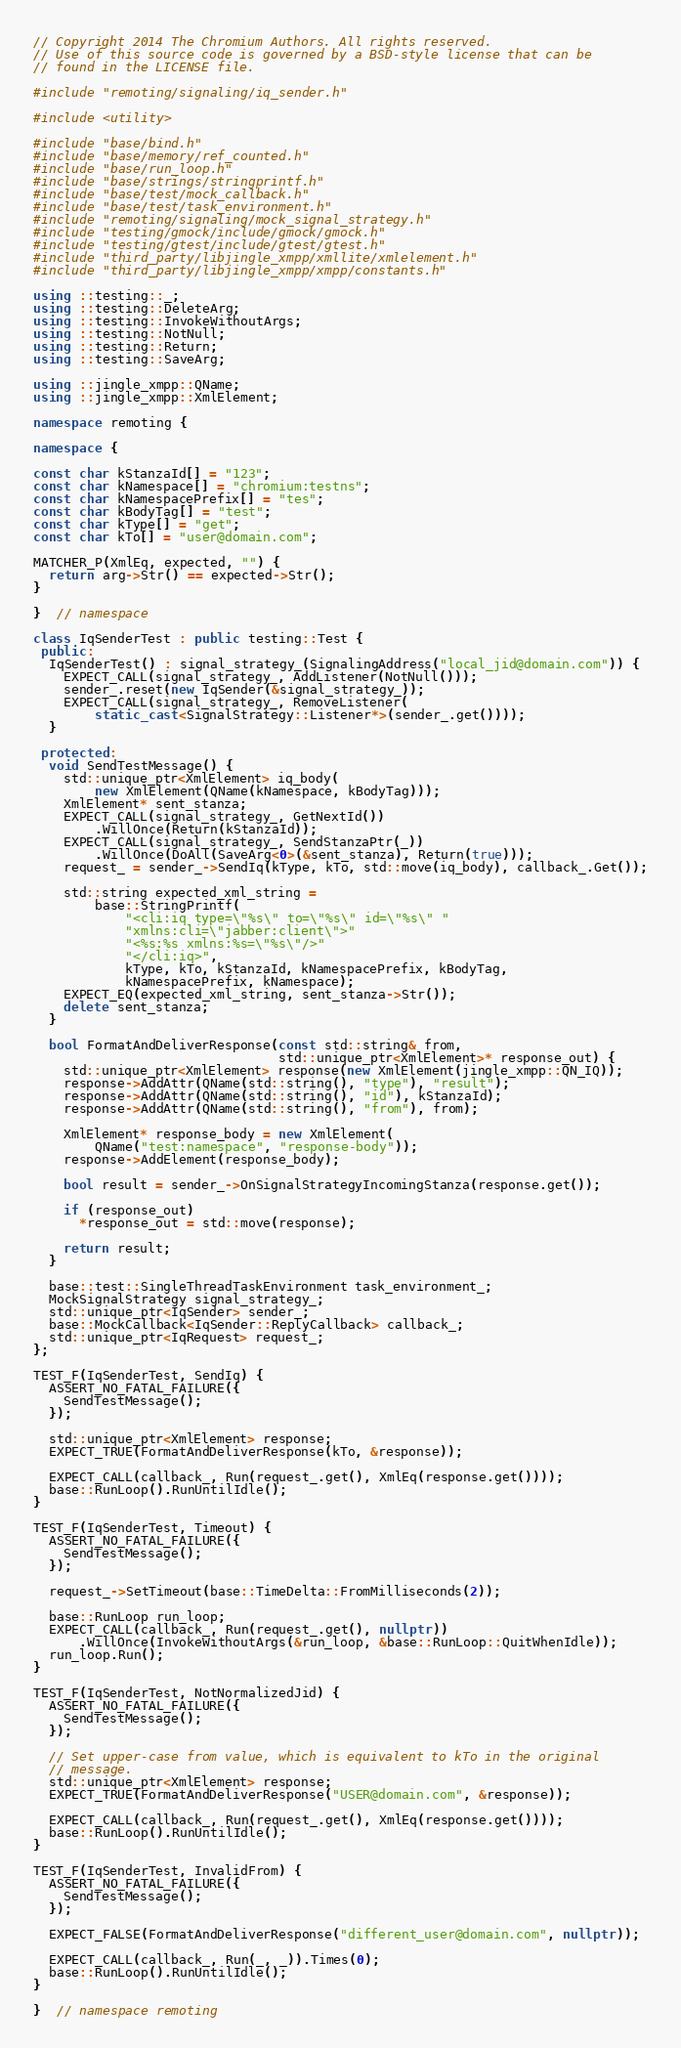Convert code to text. <code><loc_0><loc_0><loc_500><loc_500><_C++_>// Copyright 2014 The Chromium Authors. All rights reserved.
// Use of this source code is governed by a BSD-style license that can be
// found in the LICENSE file.

#include "remoting/signaling/iq_sender.h"

#include <utility>

#include "base/bind.h"
#include "base/memory/ref_counted.h"
#include "base/run_loop.h"
#include "base/strings/stringprintf.h"
#include "base/test/mock_callback.h"
#include "base/test/task_environment.h"
#include "remoting/signaling/mock_signal_strategy.h"
#include "testing/gmock/include/gmock/gmock.h"
#include "testing/gtest/include/gtest/gtest.h"
#include "third_party/libjingle_xmpp/xmllite/xmlelement.h"
#include "third_party/libjingle_xmpp/xmpp/constants.h"

using ::testing::_;
using ::testing::DeleteArg;
using ::testing::InvokeWithoutArgs;
using ::testing::NotNull;
using ::testing::Return;
using ::testing::SaveArg;

using ::jingle_xmpp::QName;
using ::jingle_xmpp::XmlElement;

namespace remoting {

namespace {

const char kStanzaId[] = "123";
const char kNamespace[] = "chromium:testns";
const char kNamespacePrefix[] = "tes";
const char kBodyTag[] = "test";
const char kType[] = "get";
const char kTo[] = "user@domain.com";

MATCHER_P(XmlEq, expected, "") {
  return arg->Str() == expected->Str();
}

}  // namespace

class IqSenderTest : public testing::Test {
 public:
  IqSenderTest() : signal_strategy_(SignalingAddress("local_jid@domain.com")) {
    EXPECT_CALL(signal_strategy_, AddListener(NotNull()));
    sender_.reset(new IqSender(&signal_strategy_));
    EXPECT_CALL(signal_strategy_, RemoveListener(
        static_cast<SignalStrategy::Listener*>(sender_.get())));
  }

 protected:
  void SendTestMessage() {
    std::unique_ptr<XmlElement> iq_body(
        new XmlElement(QName(kNamespace, kBodyTag)));
    XmlElement* sent_stanza;
    EXPECT_CALL(signal_strategy_, GetNextId())
        .WillOnce(Return(kStanzaId));
    EXPECT_CALL(signal_strategy_, SendStanzaPtr(_))
        .WillOnce(DoAll(SaveArg<0>(&sent_stanza), Return(true)));
    request_ = sender_->SendIq(kType, kTo, std::move(iq_body), callback_.Get());

    std::string expected_xml_string =
        base::StringPrintf(
            "<cli:iq type=\"%s\" to=\"%s\" id=\"%s\" "
            "xmlns:cli=\"jabber:client\">"
            "<%s:%s xmlns:%s=\"%s\"/>"
            "</cli:iq>",
            kType, kTo, kStanzaId, kNamespacePrefix, kBodyTag,
            kNamespacePrefix, kNamespace);
    EXPECT_EQ(expected_xml_string, sent_stanza->Str());
    delete sent_stanza;
  }

  bool FormatAndDeliverResponse(const std::string& from,
                                std::unique_ptr<XmlElement>* response_out) {
    std::unique_ptr<XmlElement> response(new XmlElement(jingle_xmpp::QN_IQ));
    response->AddAttr(QName(std::string(), "type"), "result");
    response->AddAttr(QName(std::string(), "id"), kStanzaId);
    response->AddAttr(QName(std::string(), "from"), from);

    XmlElement* response_body = new XmlElement(
        QName("test:namespace", "response-body"));
    response->AddElement(response_body);

    bool result = sender_->OnSignalStrategyIncomingStanza(response.get());

    if (response_out)
      *response_out = std::move(response);

    return result;
  }

  base::test::SingleThreadTaskEnvironment task_environment_;
  MockSignalStrategy signal_strategy_;
  std::unique_ptr<IqSender> sender_;
  base::MockCallback<IqSender::ReplyCallback> callback_;
  std::unique_ptr<IqRequest> request_;
};

TEST_F(IqSenderTest, SendIq) {
  ASSERT_NO_FATAL_FAILURE({
    SendTestMessage();
  });

  std::unique_ptr<XmlElement> response;
  EXPECT_TRUE(FormatAndDeliverResponse(kTo, &response));

  EXPECT_CALL(callback_, Run(request_.get(), XmlEq(response.get())));
  base::RunLoop().RunUntilIdle();
}

TEST_F(IqSenderTest, Timeout) {
  ASSERT_NO_FATAL_FAILURE({
    SendTestMessage();
  });

  request_->SetTimeout(base::TimeDelta::FromMilliseconds(2));

  base::RunLoop run_loop;
  EXPECT_CALL(callback_, Run(request_.get(), nullptr))
      .WillOnce(InvokeWithoutArgs(&run_loop, &base::RunLoop::QuitWhenIdle));
  run_loop.Run();
}

TEST_F(IqSenderTest, NotNormalizedJid) {
  ASSERT_NO_FATAL_FAILURE({
    SendTestMessage();
  });

  // Set upper-case from value, which is equivalent to kTo in the original
  // message.
  std::unique_ptr<XmlElement> response;
  EXPECT_TRUE(FormatAndDeliverResponse("USER@domain.com", &response));

  EXPECT_CALL(callback_, Run(request_.get(), XmlEq(response.get())));
  base::RunLoop().RunUntilIdle();
}

TEST_F(IqSenderTest, InvalidFrom) {
  ASSERT_NO_FATAL_FAILURE({
    SendTestMessage();
  });

  EXPECT_FALSE(FormatAndDeliverResponse("different_user@domain.com", nullptr));

  EXPECT_CALL(callback_, Run(_, _)).Times(0);
  base::RunLoop().RunUntilIdle();
}

}  // namespace remoting
</code> 